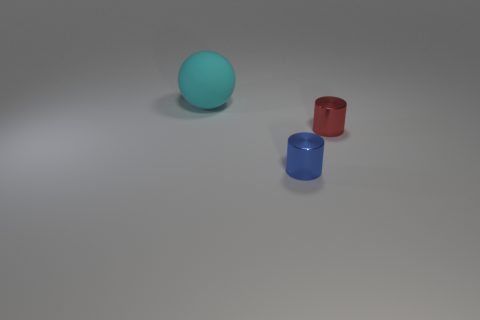Add 2 big brown balls. How many objects exist? 5 Subtract all cylinders. How many objects are left? 1 Subtract 0 gray spheres. How many objects are left? 3 Subtract all tiny things. Subtract all large matte balls. How many objects are left? 0 Add 3 small blue cylinders. How many small blue cylinders are left? 4 Add 2 blue cylinders. How many blue cylinders exist? 3 